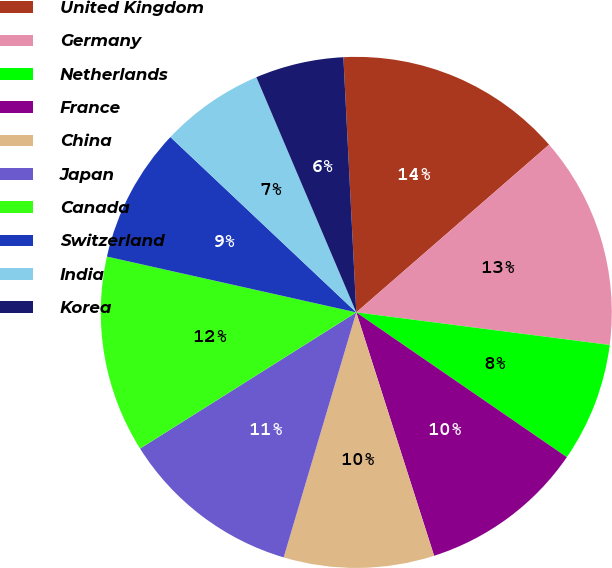Convert chart. <chart><loc_0><loc_0><loc_500><loc_500><pie_chart><fcel>United Kingdom<fcel>Germany<fcel>Netherlands<fcel>France<fcel>China<fcel>Japan<fcel>Canada<fcel>Switzerland<fcel>India<fcel>Korea<nl><fcel>14.41%<fcel>13.43%<fcel>7.55%<fcel>10.49%<fcel>9.51%<fcel>11.47%<fcel>12.45%<fcel>8.53%<fcel>6.57%<fcel>5.59%<nl></chart> 